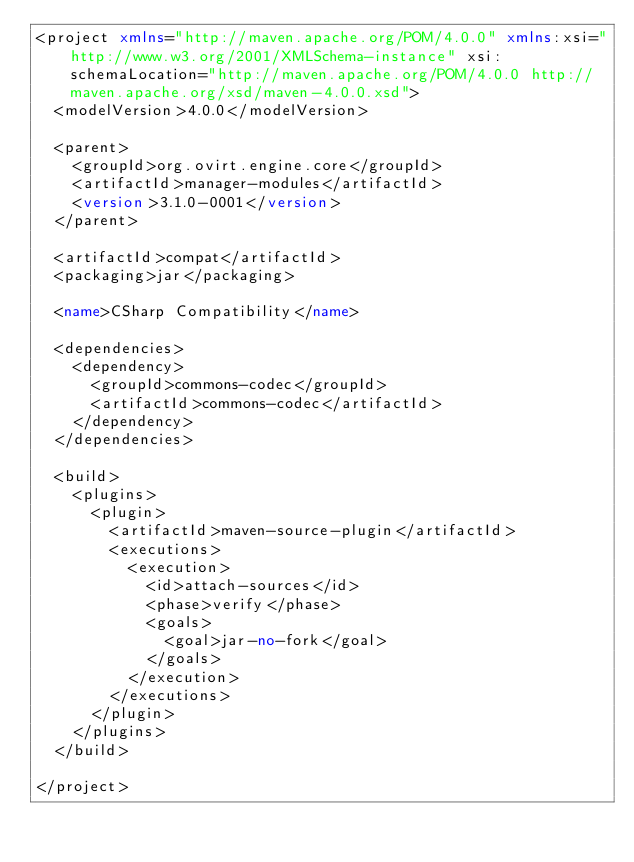<code> <loc_0><loc_0><loc_500><loc_500><_XML_><project xmlns="http://maven.apache.org/POM/4.0.0" xmlns:xsi="http://www.w3.org/2001/XMLSchema-instance" xsi:schemaLocation="http://maven.apache.org/POM/4.0.0 http://maven.apache.org/xsd/maven-4.0.0.xsd">
  <modelVersion>4.0.0</modelVersion>

  <parent>
    <groupId>org.ovirt.engine.core</groupId>
    <artifactId>manager-modules</artifactId>
    <version>3.1.0-0001</version>
  </parent>

  <artifactId>compat</artifactId>
  <packaging>jar</packaging>

  <name>CSharp Compatibility</name>

  <dependencies>
    <dependency>
      <groupId>commons-codec</groupId>
      <artifactId>commons-codec</artifactId>
    </dependency>
  </dependencies>

  <build>
    <plugins>
      <plugin>
        <artifactId>maven-source-plugin</artifactId>
        <executions>
          <execution>
            <id>attach-sources</id>
            <phase>verify</phase>
            <goals>
              <goal>jar-no-fork</goal>
            </goals>
          </execution>
        </executions>
      </plugin>
    </plugins>
  </build>

</project>
</code> 